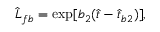Convert formula to latex. <formula><loc_0><loc_0><loc_500><loc_500>\hat { L } _ { f b } = \exp [ b _ { 2 } ( \hat { t } - \hat { t } _ { b 2 } ) ] ,</formula> 